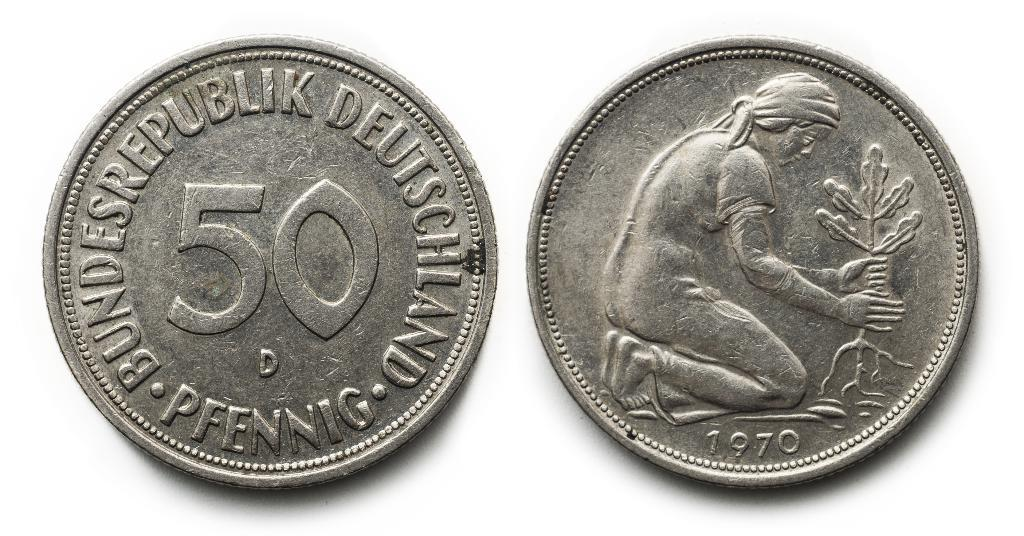Provide a one-sentence caption for the provided image. Two 50 pfennig coins are shown side by side. 